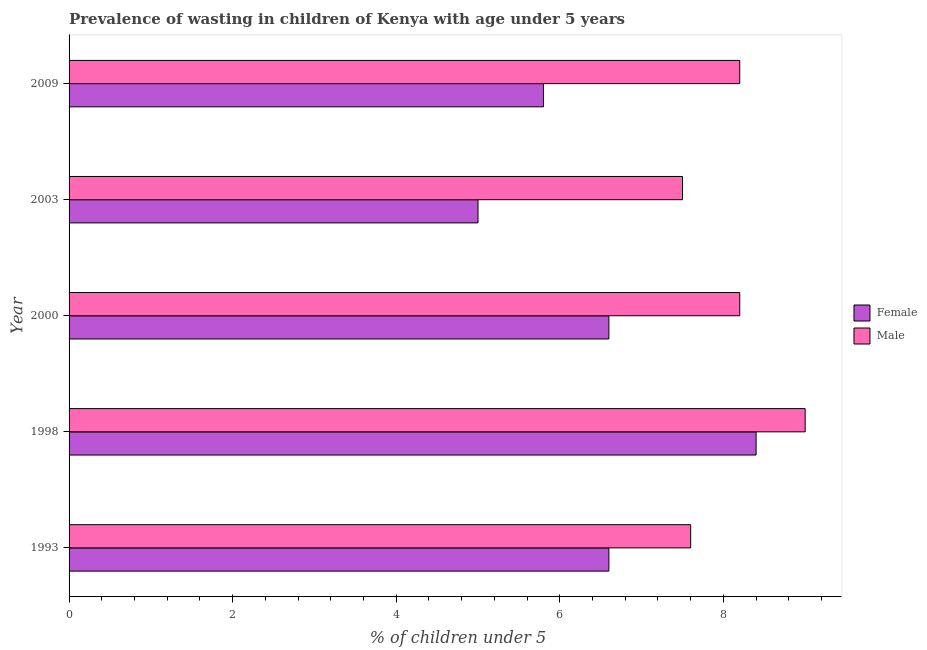What is the label of the 2nd group of bars from the top?
Offer a terse response. 2003. In how many cases, is the number of bars for a given year not equal to the number of legend labels?
Offer a terse response. 0. Across all years, what is the maximum percentage of undernourished female children?
Your response must be concise. 8.4. In which year was the percentage of undernourished male children minimum?
Offer a very short reply. 2003. What is the total percentage of undernourished female children in the graph?
Offer a terse response. 32.4. What is the difference between the percentage of undernourished male children in 1998 and the percentage of undernourished female children in 1993?
Your answer should be very brief. 2.4. What is the average percentage of undernourished male children per year?
Offer a terse response. 8.1. What is the ratio of the percentage of undernourished male children in 2003 to that in 2009?
Offer a very short reply. 0.92. Is the difference between the percentage of undernourished male children in 1993 and 2000 greater than the difference between the percentage of undernourished female children in 1993 and 2000?
Make the answer very short. No. What is the difference between the highest and the second highest percentage of undernourished male children?
Provide a succinct answer. 0.8. Is the sum of the percentage of undernourished male children in 2000 and 2003 greater than the maximum percentage of undernourished female children across all years?
Your answer should be compact. Yes. Are all the bars in the graph horizontal?
Provide a short and direct response. Yes. What is the difference between two consecutive major ticks on the X-axis?
Provide a short and direct response. 2. Does the graph contain any zero values?
Make the answer very short. No. What is the title of the graph?
Your answer should be very brief. Prevalence of wasting in children of Kenya with age under 5 years. Does "Time to export" appear as one of the legend labels in the graph?
Give a very brief answer. No. What is the label or title of the X-axis?
Make the answer very short.  % of children under 5. What is the label or title of the Y-axis?
Provide a short and direct response. Year. What is the  % of children under 5 in Female in 1993?
Offer a terse response. 6.6. What is the  % of children under 5 of Male in 1993?
Keep it short and to the point. 7.6. What is the  % of children under 5 in Female in 1998?
Provide a short and direct response. 8.4. What is the  % of children under 5 of Female in 2000?
Keep it short and to the point. 6.6. What is the  % of children under 5 in Male in 2000?
Give a very brief answer. 8.2. What is the  % of children under 5 of Female in 2003?
Offer a very short reply. 5. What is the  % of children under 5 in Female in 2009?
Your answer should be very brief. 5.8. What is the  % of children under 5 in Male in 2009?
Your response must be concise. 8.2. Across all years, what is the maximum  % of children under 5 of Female?
Provide a succinct answer. 8.4. Across all years, what is the maximum  % of children under 5 of Male?
Your answer should be very brief. 9. What is the total  % of children under 5 of Female in the graph?
Your answer should be compact. 32.4. What is the total  % of children under 5 of Male in the graph?
Provide a succinct answer. 40.5. What is the difference between the  % of children under 5 of Male in 1993 and that in 1998?
Provide a succinct answer. -1.4. What is the difference between the  % of children under 5 of Female in 1993 and that in 2003?
Provide a short and direct response. 1.6. What is the difference between the  % of children under 5 of Male in 1993 and that in 2003?
Offer a very short reply. 0.1. What is the difference between the  % of children under 5 in Female in 1993 and that in 2009?
Offer a very short reply. 0.8. What is the difference between the  % of children under 5 in Female in 1998 and that in 2000?
Give a very brief answer. 1.8. What is the difference between the  % of children under 5 in Female in 1998 and that in 2009?
Keep it short and to the point. 2.6. What is the difference between the  % of children under 5 in Male in 1998 and that in 2009?
Provide a short and direct response. 0.8. What is the difference between the  % of children under 5 of Male in 2003 and that in 2009?
Offer a terse response. -0.7. What is the difference between the  % of children under 5 of Female in 1993 and the  % of children under 5 of Male in 2000?
Offer a terse response. -1.6. What is the difference between the  % of children under 5 in Female in 1993 and the  % of children under 5 in Male in 2003?
Ensure brevity in your answer.  -0.9. What is the difference between the  % of children under 5 of Female in 2000 and the  % of children under 5 of Male in 2003?
Keep it short and to the point. -0.9. What is the difference between the  % of children under 5 in Female in 2000 and the  % of children under 5 in Male in 2009?
Ensure brevity in your answer.  -1.6. What is the average  % of children under 5 in Female per year?
Offer a terse response. 6.48. What is the average  % of children under 5 in Male per year?
Provide a succinct answer. 8.1. In the year 1993, what is the difference between the  % of children under 5 in Female and  % of children under 5 in Male?
Your answer should be compact. -1. In the year 1998, what is the difference between the  % of children under 5 of Female and  % of children under 5 of Male?
Keep it short and to the point. -0.6. In the year 2009, what is the difference between the  % of children under 5 in Female and  % of children under 5 in Male?
Make the answer very short. -2.4. What is the ratio of the  % of children under 5 in Female in 1993 to that in 1998?
Provide a succinct answer. 0.79. What is the ratio of the  % of children under 5 in Male in 1993 to that in 1998?
Offer a terse response. 0.84. What is the ratio of the  % of children under 5 in Male in 1993 to that in 2000?
Ensure brevity in your answer.  0.93. What is the ratio of the  % of children under 5 of Female in 1993 to that in 2003?
Offer a terse response. 1.32. What is the ratio of the  % of children under 5 in Male in 1993 to that in 2003?
Ensure brevity in your answer.  1.01. What is the ratio of the  % of children under 5 of Female in 1993 to that in 2009?
Provide a short and direct response. 1.14. What is the ratio of the  % of children under 5 in Male in 1993 to that in 2009?
Ensure brevity in your answer.  0.93. What is the ratio of the  % of children under 5 of Female in 1998 to that in 2000?
Ensure brevity in your answer.  1.27. What is the ratio of the  % of children under 5 in Male in 1998 to that in 2000?
Provide a short and direct response. 1.1. What is the ratio of the  % of children under 5 in Female in 1998 to that in 2003?
Provide a short and direct response. 1.68. What is the ratio of the  % of children under 5 of Male in 1998 to that in 2003?
Keep it short and to the point. 1.2. What is the ratio of the  % of children under 5 of Female in 1998 to that in 2009?
Your answer should be compact. 1.45. What is the ratio of the  % of children under 5 in Male in 1998 to that in 2009?
Give a very brief answer. 1.1. What is the ratio of the  % of children under 5 in Female in 2000 to that in 2003?
Offer a terse response. 1.32. What is the ratio of the  % of children under 5 in Male in 2000 to that in 2003?
Offer a terse response. 1.09. What is the ratio of the  % of children under 5 of Female in 2000 to that in 2009?
Offer a terse response. 1.14. What is the ratio of the  % of children under 5 of Female in 2003 to that in 2009?
Your response must be concise. 0.86. What is the ratio of the  % of children under 5 in Male in 2003 to that in 2009?
Ensure brevity in your answer.  0.91. What is the difference between the highest and the second highest  % of children under 5 of Female?
Your response must be concise. 1.8. What is the difference between the highest and the second highest  % of children under 5 of Male?
Offer a terse response. 0.8. 